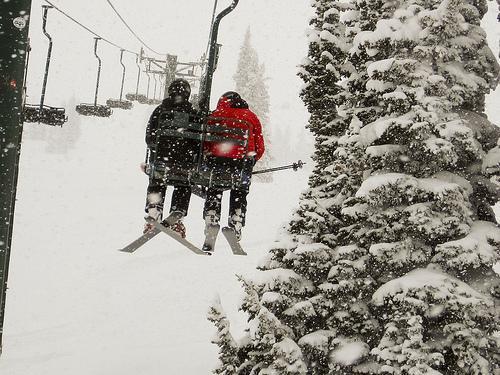How many people are in the picture?
Give a very brief answer. 2. 